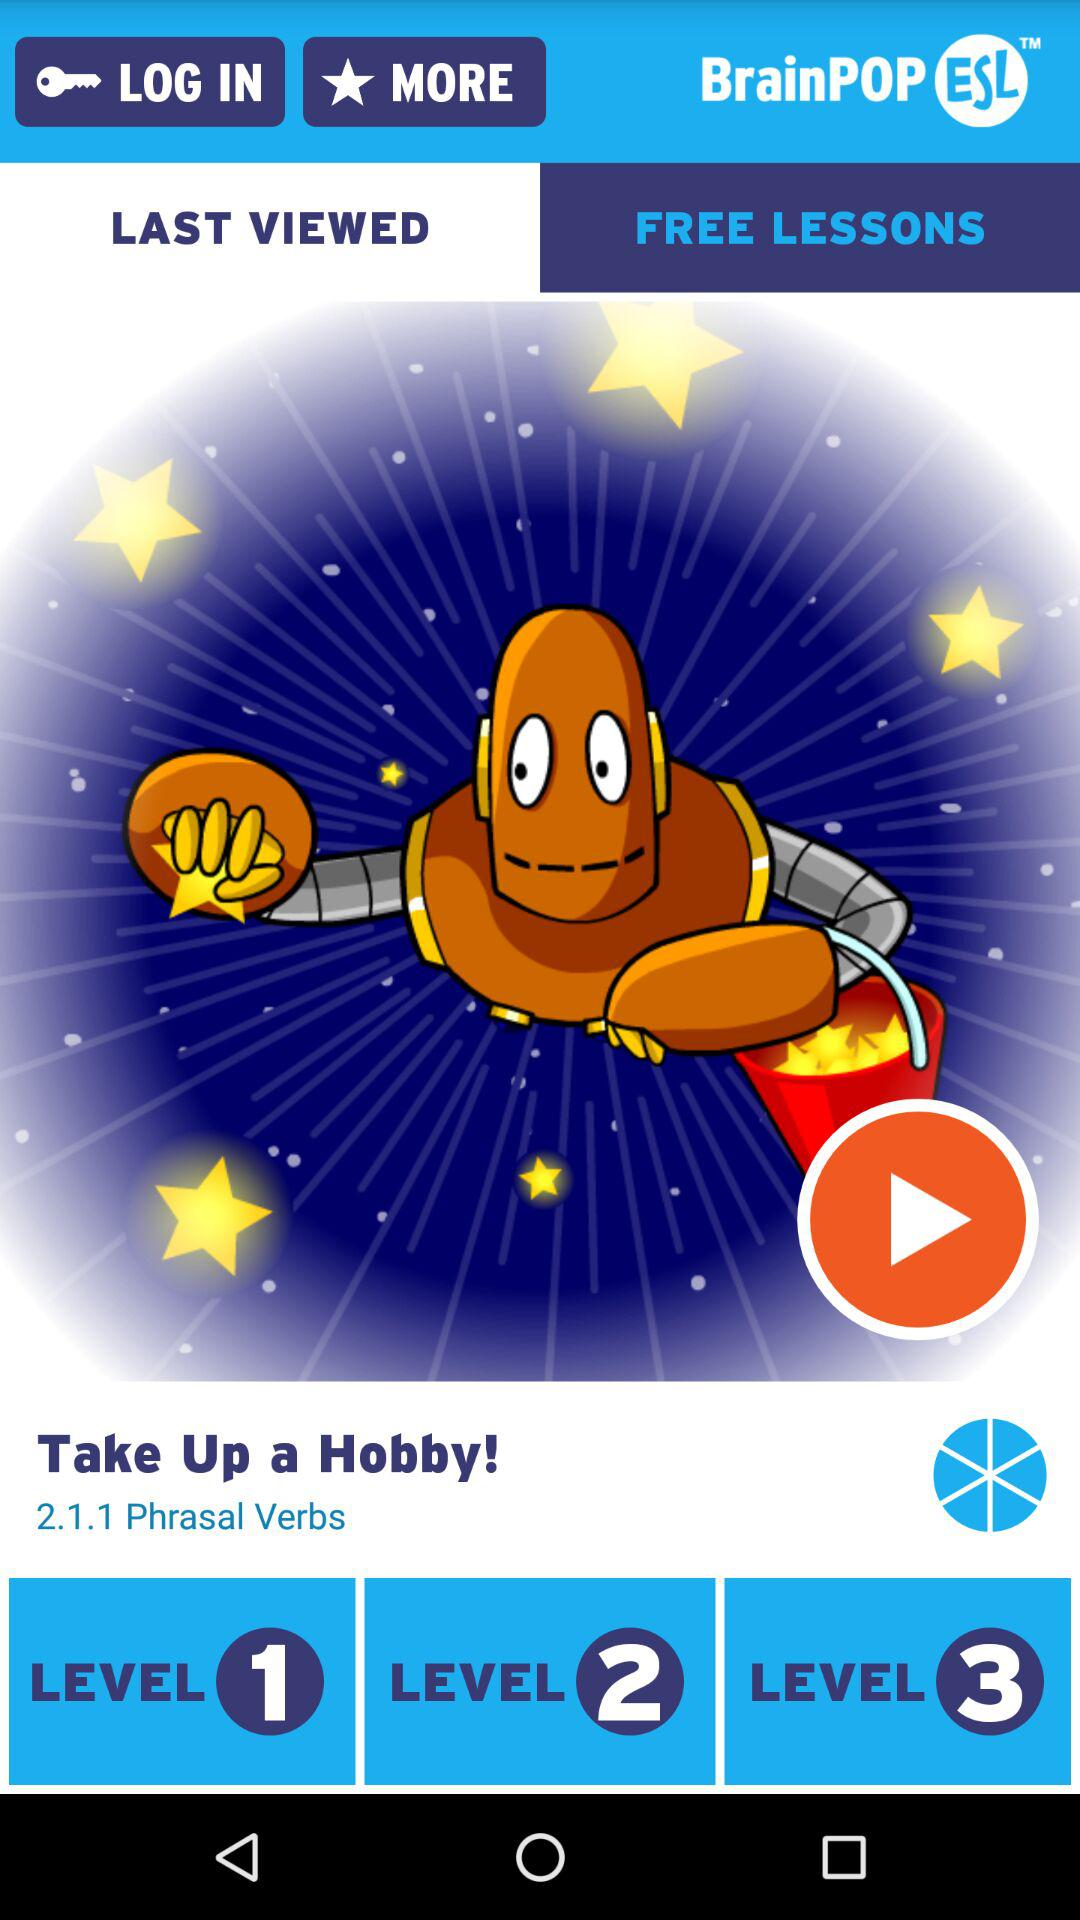How many levels of difficulty are there in this lesson?
Answer the question using a single word or phrase. 3 